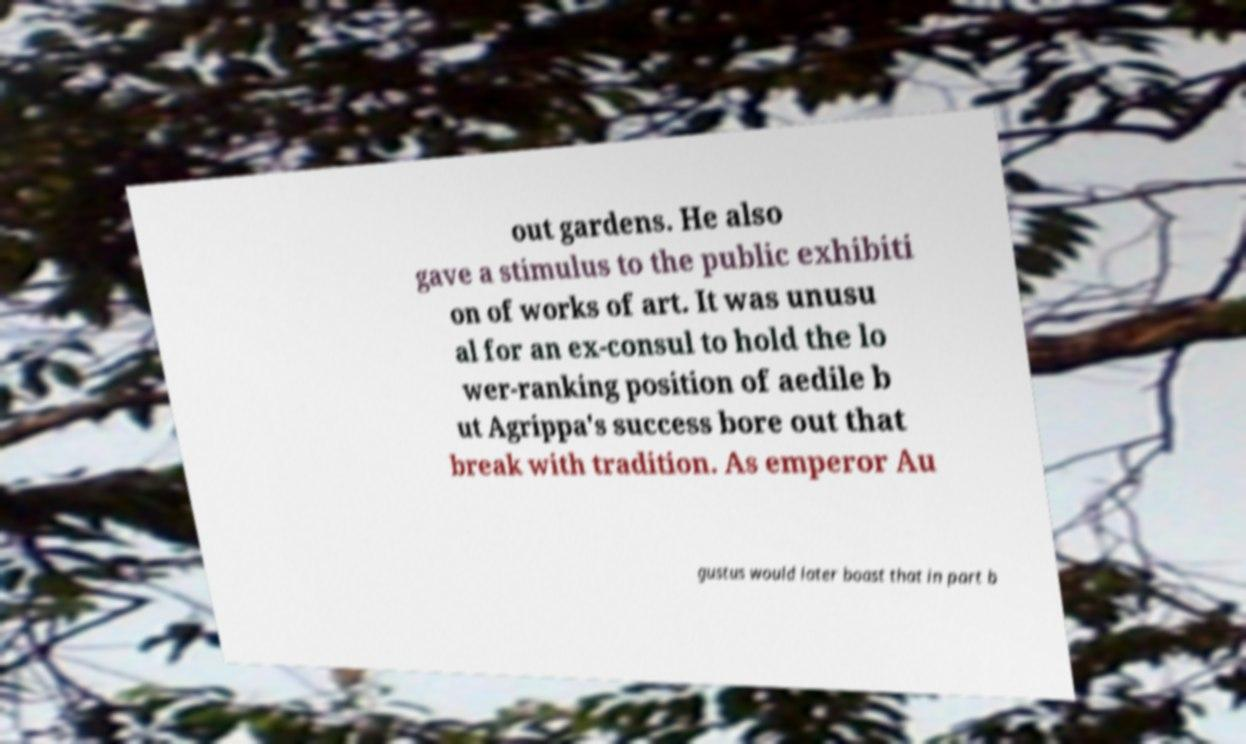I need the written content from this picture converted into text. Can you do that? out gardens. He also gave a stimulus to the public exhibiti on of works of art. It was unusu al for an ex-consul to hold the lo wer-ranking position of aedile b ut Agrippa's success bore out that break with tradition. As emperor Au gustus would later boast that in part b 